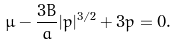<formula> <loc_0><loc_0><loc_500><loc_500>\mu - \frac { 3 B } { a } | p | ^ { 3 / 2 } + 3 p = 0 .</formula> 